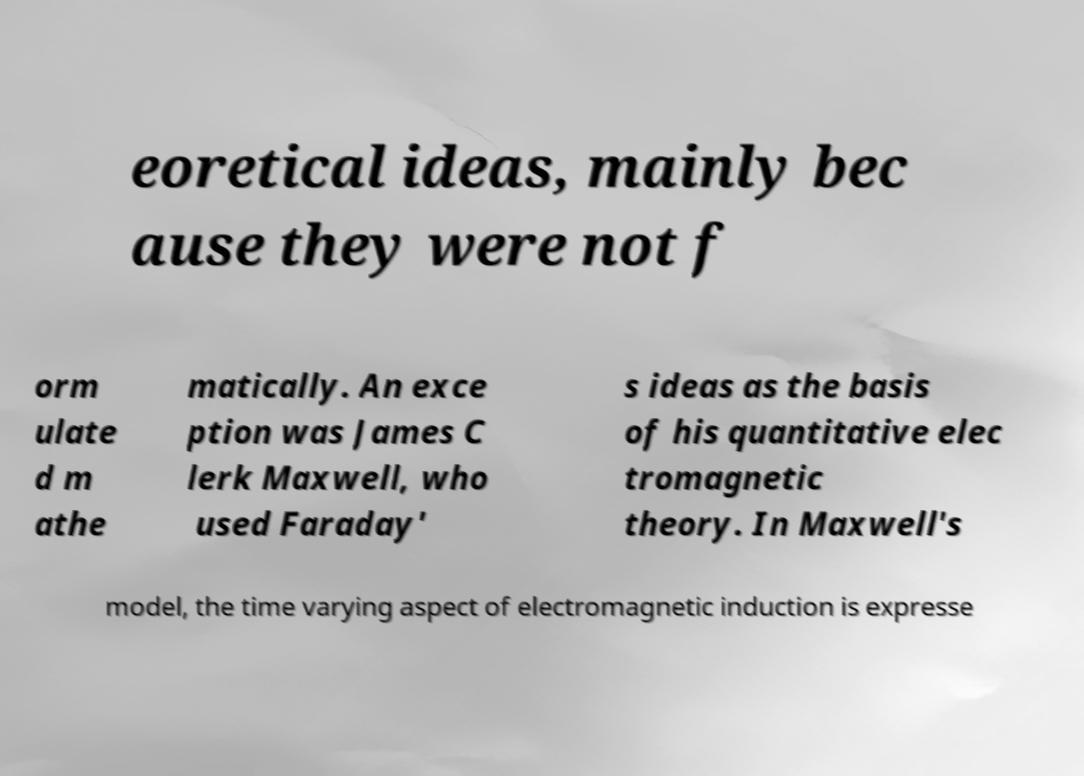Could you extract and type out the text from this image? eoretical ideas, mainly bec ause they were not f orm ulate d m athe matically. An exce ption was James C lerk Maxwell, who used Faraday' s ideas as the basis of his quantitative elec tromagnetic theory. In Maxwell's model, the time varying aspect of electromagnetic induction is expresse 